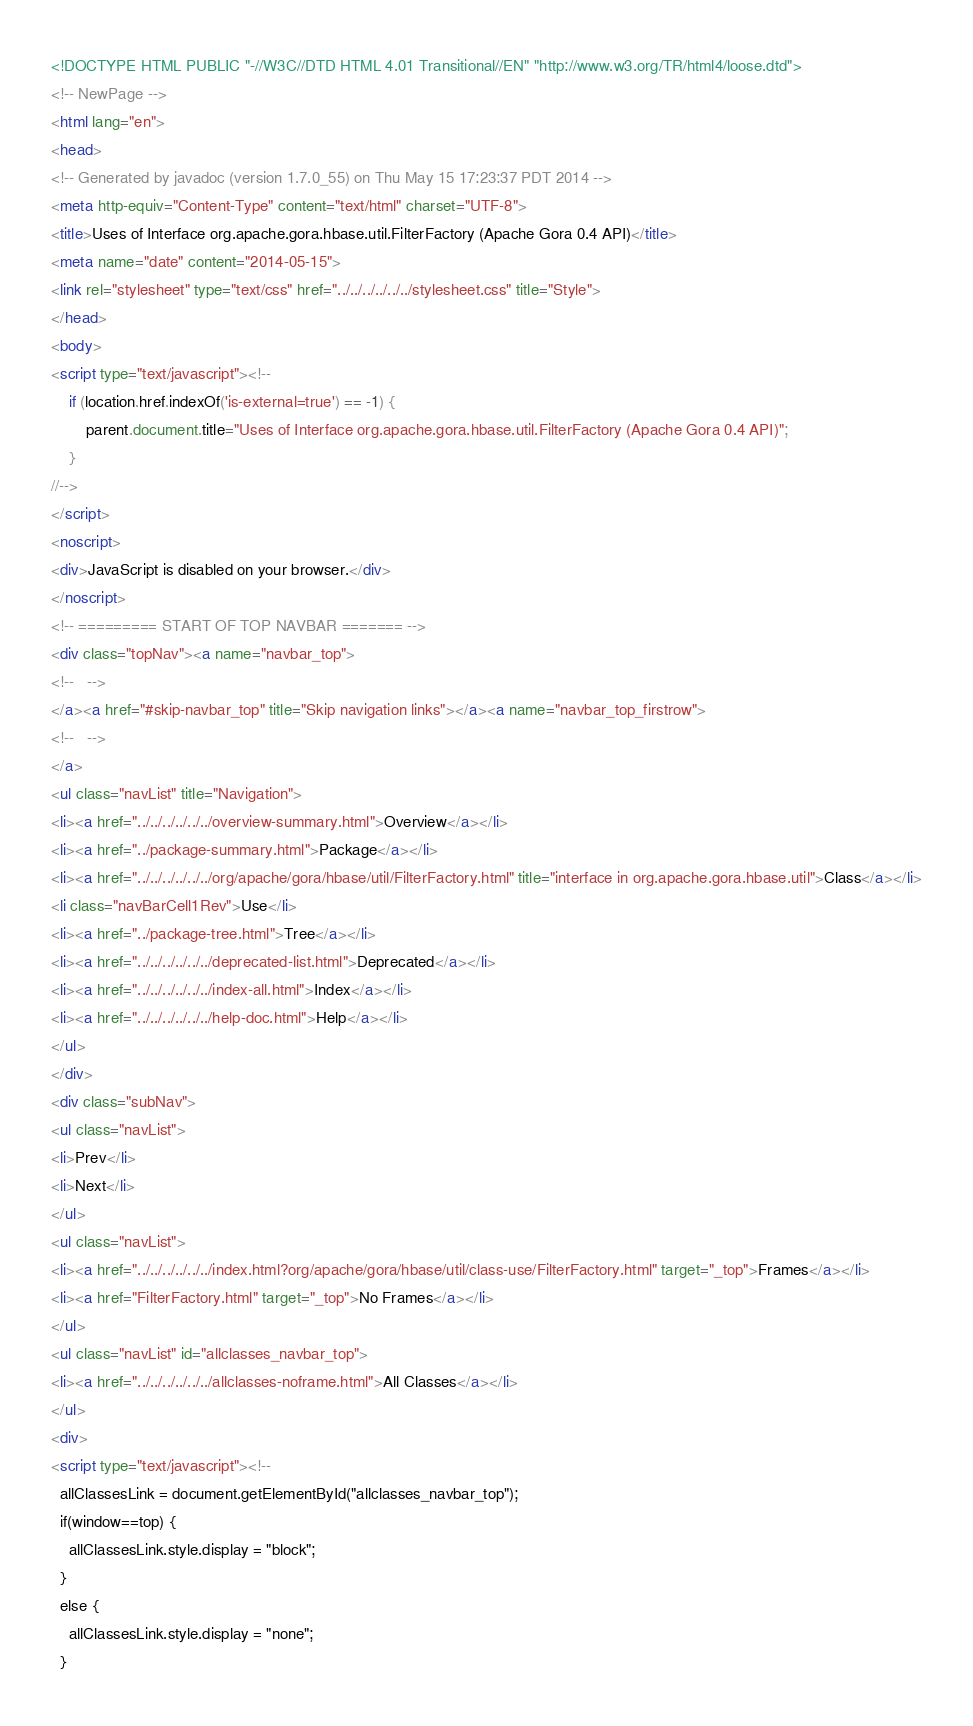Convert code to text. <code><loc_0><loc_0><loc_500><loc_500><_HTML_><!DOCTYPE HTML PUBLIC "-//W3C//DTD HTML 4.01 Transitional//EN" "http://www.w3.org/TR/html4/loose.dtd">
<!-- NewPage -->
<html lang="en">
<head>
<!-- Generated by javadoc (version 1.7.0_55) on Thu May 15 17:23:37 PDT 2014 -->
<meta http-equiv="Content-Type" content="text/html" charset="UTF-8">
<title>Uses of Interface org.apache.gora.hbase.util.FilterFactory (Apache Gora 0.4 API)</title>
<meta name="date" content="2014-05-15">
<link rel="stylesheet" type="text/css" href="../../../../../../stylesheet.css" title="Style">
</head>
<body>
<script type="text/javascript"><!--
    if (location.href.indexOf('is-external=true') == -1) {
        parent.document.title="Uses of Interface org.apache.gora.hbase.util.FilterFactory (Apache Gora 0.4 API)";
    }
//-->
</script>
<noscript>
<div>JavaScript is disabled on your browser.</div>
</noscript>
<!-- ========= START OF TOP NAVBAR ======= -->
<div class="topNav"><a name="navbar_top">
<!--   -->
</a><a href="#skip-navbar_top" title="Skip navigation links"></a><a name="navbar_top_firstrow">
<!--   -->
</a>
<ul class="navList" title="Navigation">
<li><a href="../../../../../../overview-summary.html">Overview</a></li>
<li><a href="../package-summary.html">Package</a></li>
<li><a href="../../../../../../org/apache/gora/hbase/util/FilterFactory.html" title="interface in org.apache.gora.hbase.util">Class</a></li>
<li class="navBarCell1Rev">Use</li>
<li><a href="../package-tree.html">Tree</a></li>
<li><a href="../../../../../../deprecated-list.html">Deprecated</a></li>
<li><a href="../../../../../../index-all.html">Index</a></li>
<li><a href="../../../../../../help-doc.html">Help</a></li>
</ul>
</div>
<div class="subNav">
<ul class="navList">
<li>Prev</li>
<li>Next</li>
</ul>
<ul class="navList">
<li><a href="../../../../../../index.html?org/apache/gora/hbase/util/class-use/FilterFactory.html" target="_top">Frames</a></li>
<li><a href="FilterFactory.html" target="_top">No Frames</a></li>
</ul>
<ul class="navList" id="allclasses_navbar_top">
<li><a href="../../../../../../allclasses-noframe.html">All Classes</a></li>
</ul>
<div>
<script type="text/javascript"><!--
  allClassesLink = document.getElementById("allclasses_navbar_top");
  if(window==top) {
    allClassesLink.style.display = "block";
  }
  else {
    allClassesLink.style.display = "none";
  }</code> 